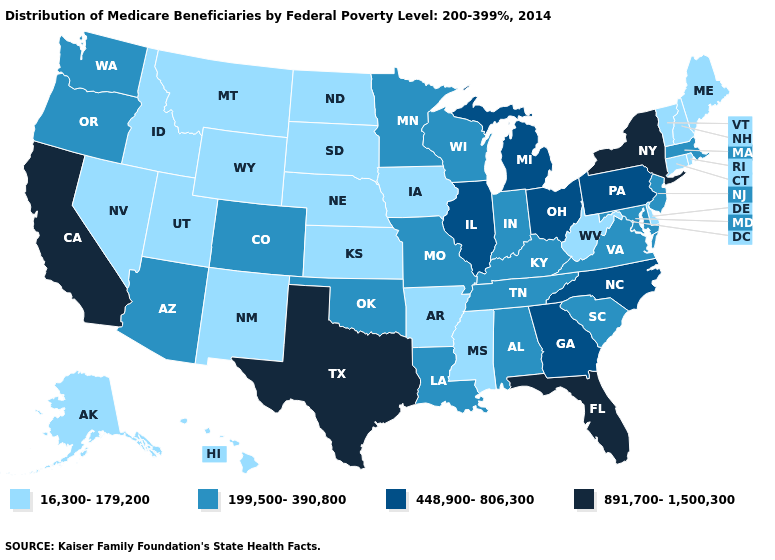Does Alaska have the highest value in the USA?
Be succinct. No. Name the states that have a value in the range 199,500-390,800?
Write a very short answer. Alabama, Arizona, Colorado, Indiana, Kentucky, Louisiana, Maryland, Massachusetts, Minnesota, Missouri, New Jersey, Oklahoma, Oregon, South Carolina, Tennessee, Virginia, Washington, Wisconsin. Name the states that have a value in the range 448,900-806,300?
Keep it brief. Georgia, Illinois, Michigan, North Carolina, Ohio, Pennsylvania. What is the value of New Hampshire?
Keep it brief. 16,300-179,200. Does Florida have the highest value in the USA?
Answer briefly. Yes. What is the value of Alaska?
Write a very short answer. 16,300-179,200. What is the lowest value in states that border South Carolina?
Be succinct. 448,900-806,300. What is the lowest value in the USA?
Give a very brief answer. 16,300-179,200. What is the value of Washington?
Keep it brief. 199,500-390,800. Which states hav the highest value in the West?
Short answer required. California. What is the value of Mississippi?
Quick response, please. 16,300-179,200. Name the states that have a value in the range 891,700-1,500,300?
Write a very short answer. California, Florida, New York, Texas. What is the value of South Carolina?
Write a very short answer. 199,500-390,800. What is the value of Washington?
Short answer required. 199,500-390,800. Does South Dakota have the lowest value in the MidWest?
Answer briefly. Yes. 